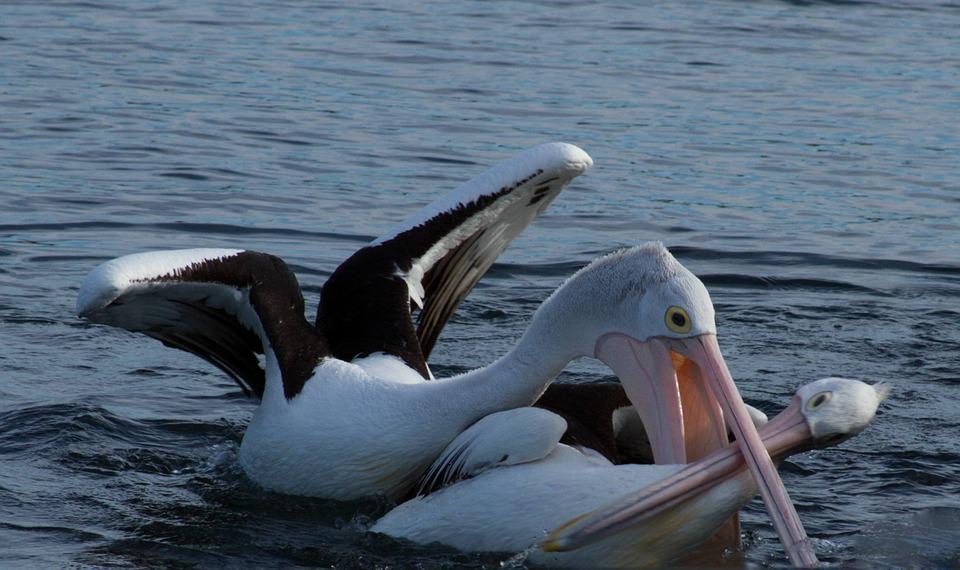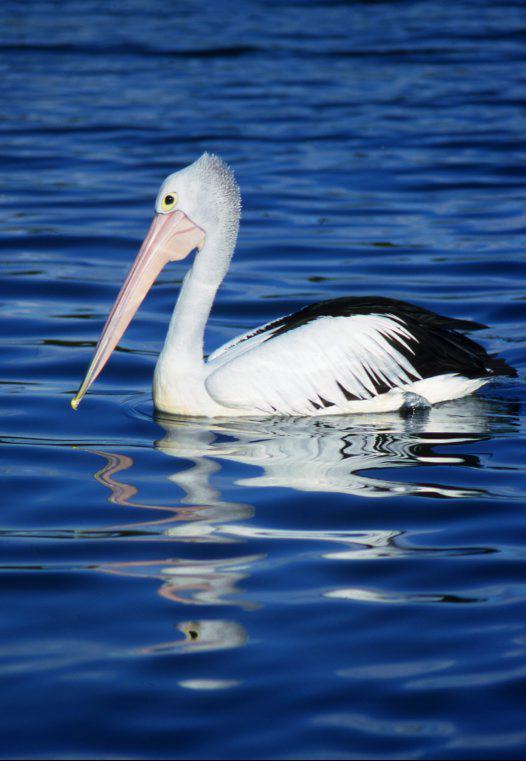The first image is the image on the left, the second image is the image on the right. Assess this claim about the two images: "One of the pelicans is flying.". Correct or not? Answer yes or no. No. 